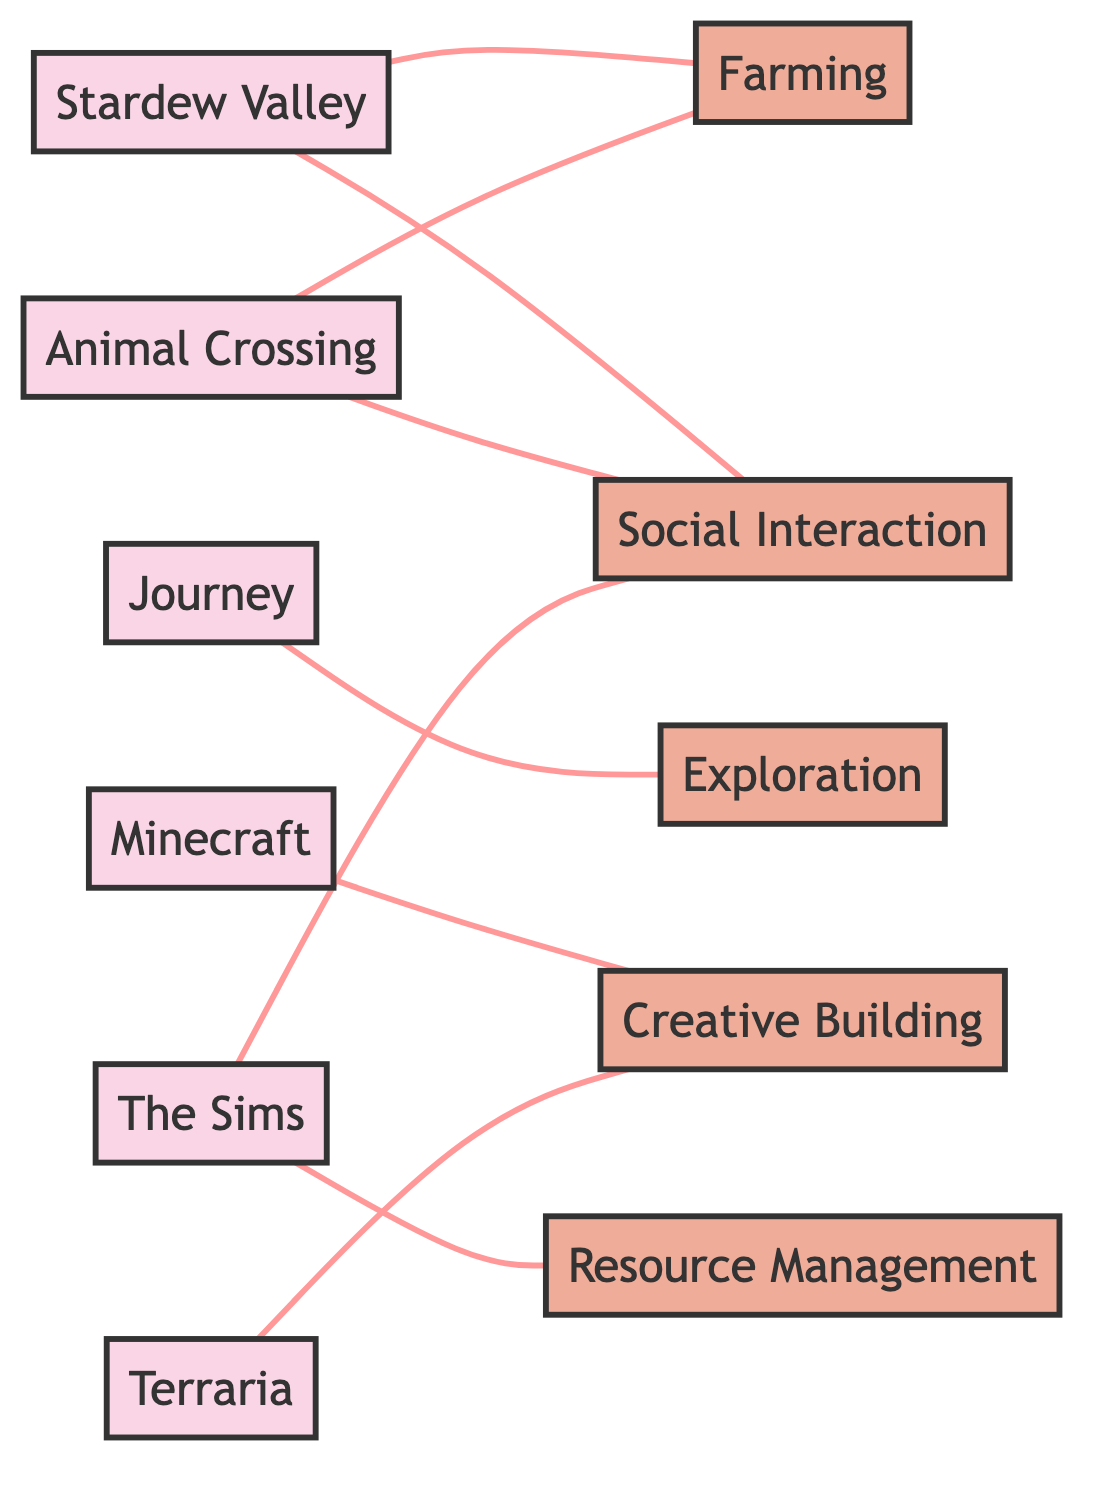What games are connected to Farming mechanics? The diagram shows two nodes that connect to the Farming mechanic: Stardew Valley and Animal Crossing. By examining the edges, we identify that both games have direct connections to the Farming node.
Answer: Stardew Valley, Animal Crossing Which game has a direct connection only to Social Interaction and no other mechanics? The diagram shows that The Sims connects to both Social Interaction and Resource Management. Therefore, it does not only connect to Social Interaction. However, examining the other games, we find that Animal Crossing also connects to Social Interaction and Farming, while Stardew Valley connects to Social Interaction and Farming too. Thus, no game has a direct connection only to Social Interaction.
Answer: None How many total nodes are represented in the diagram? By counting the nodes present in the diagram, we see there are 11 nodes total – 6 games and 5 mechanics. This includes all game titles and mechanics listed in the nodes section of the data.
Answer: 11 Which mechanic is associated with both Stardew Valley and Animal Crossing? Both games connect directly to the Farming node and the Social Interaction node. Thus, we can see more than one connection but focusing on the direct common mechanics gives us Farming.
Answer: Farming How many edges are there in total in the diagram? By analyzing the edges provided, we count all direct connections shown. There are 8 edges listed that connect the games to the respective mechanics. So, we confirm that there are a total of 8 connections.
Answer: 8 Which game connects to the Exploration mechanic? The diagram displays a direct edge from the game Journey to the Exploration mechanic. Thus, the game that connects to this mechanic is clearly laid out.
Answer: Journey 